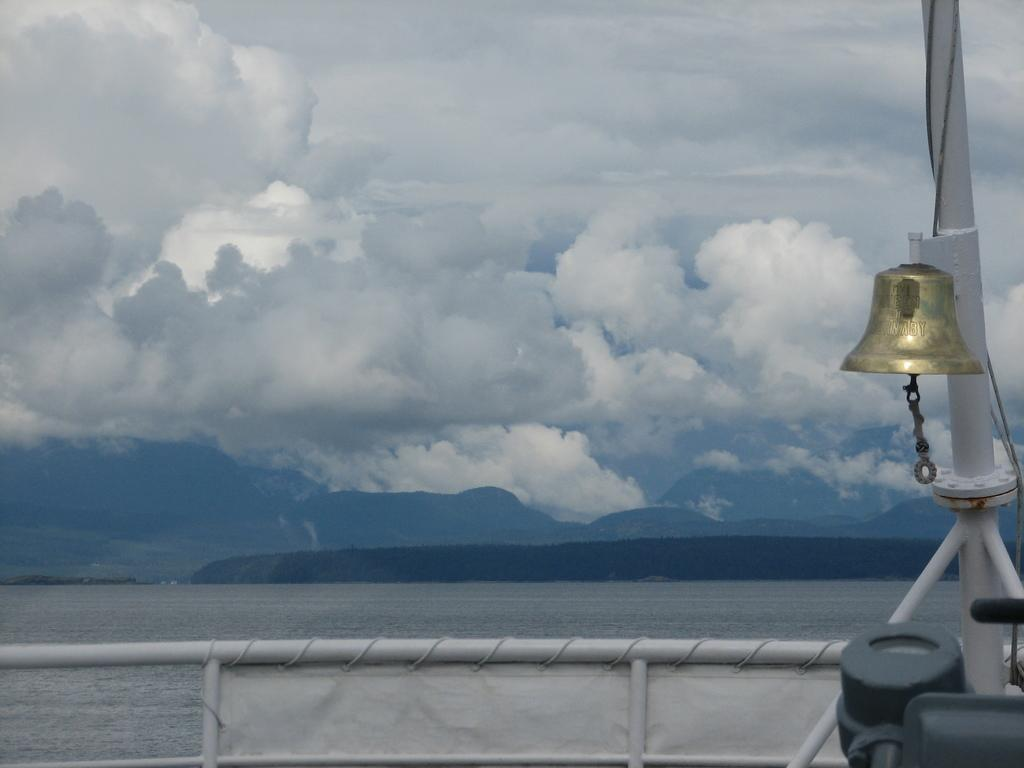What type of objects can be seen in the image? There are rods, a pole, a bell, and some unspecified objects in the image. Can you describe the background of the image? There is water, mountains, and the sky visible in the background of the image. Clouds are present in the sky. What is the weather like in the image? The presence of clouds in the sky suggests that it might be partly cloudy. What type of paper can be seen floating in the harbor in the image? There is no harbor or paper present in the image. What type of beef is being prepared on the mountain in the image? There is no beef or mountain present in the image. 